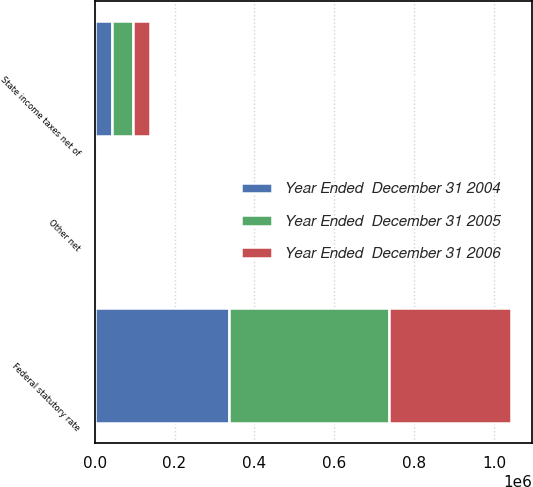<chart> <loc_0><loc_0><loc_500><loc_500><stacked_bar_chart><ecel><fcel>Federal statutory rate<fcel>State income taxes net of<fcel>Other net<nl><fcel>Year Ended  December 31 2004<fcel>337040<fcel>43491<fcel>4972<nl><fcel>Year Ended  December 31 2005<fcel>400547<fcel>53501<fcel>7188<nl><fcel>Year Ended  December 31 2006<fcel>305202<fcel>42521<fcel>1078<nl></chart> 